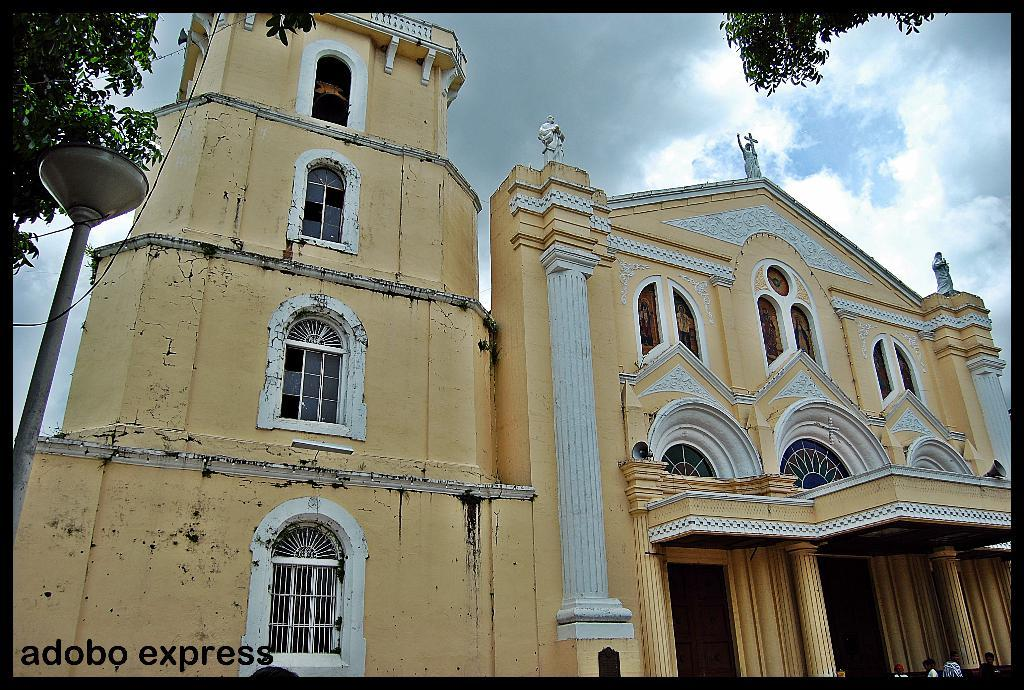What type of structure is depicted in the image? There is a building in the image. What architectural features can be seen on the building? There are statues and pillars visible on the building. What type of vegetation is present in the image? There are trees in the image. Are there any human figures in the image? Yes, there are people in the image. What other object can be seen in the image? There is a pole in the image. What is visible in the background of the image? The sky is visible in the background of the image. Can you describe the weather conditions in the image? Clouds are present in the sky, suggesting a partly cloudy day. What type of pen is being used by the fire in the image? There is no fire or pen present in the image. 